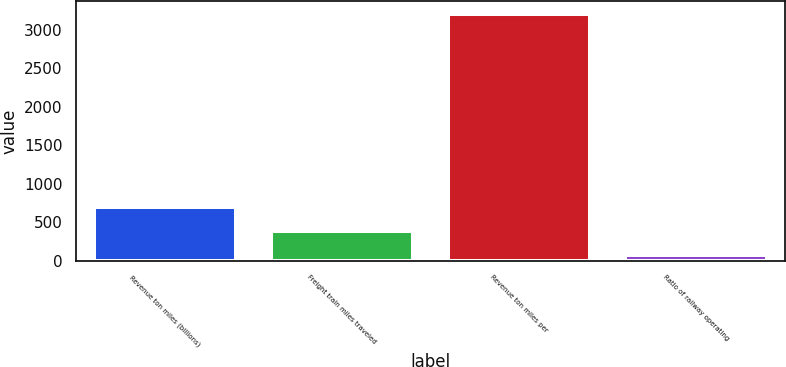Convert chart to OTSL. <chart><loc_0><loc_0><loc_500><loc_500><bar_chart><fcel>Revenue ton miles (billions)<fcel>Freight train miles traveled<fcel>Revenue ton miles per<fcel>Ratio of railway operating<nl><fcel>698.36<fcel>384.78<fcel>3207<fcel>71.2<nl></chart> 